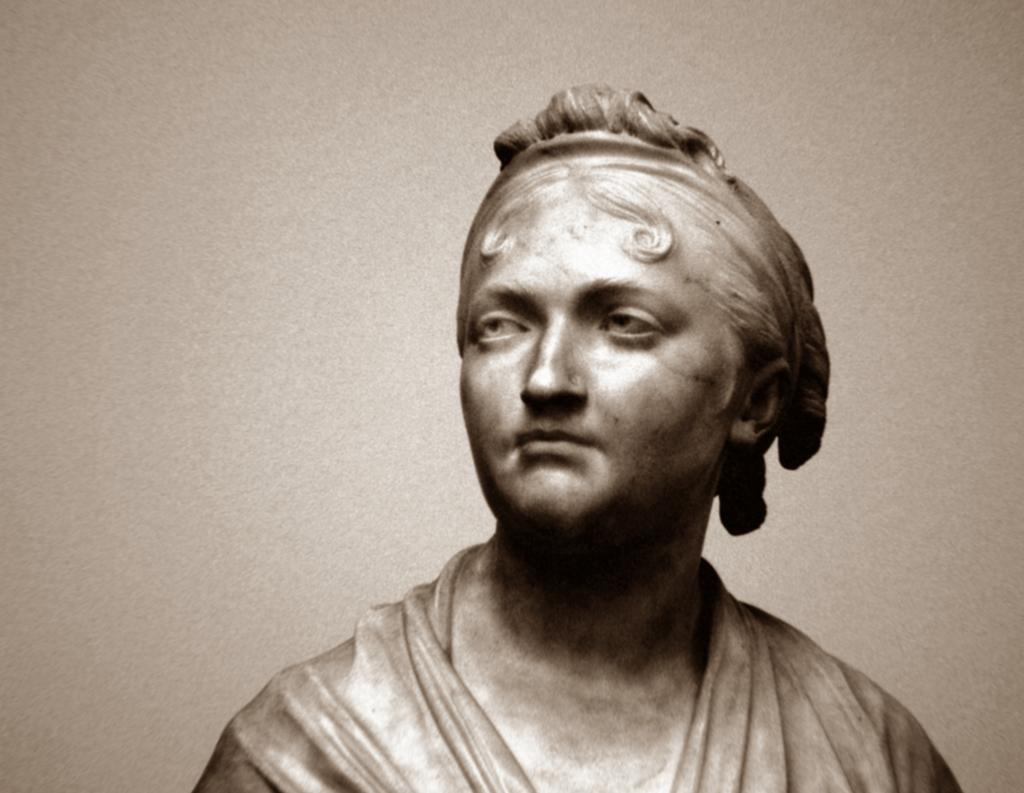What is the main subject of the image? There is a sculpture in the image. What type of eggnog is being served to the family in the office in the image? There is no mention of eggnog, a family, or an office in the image; it only features a sculpture. 